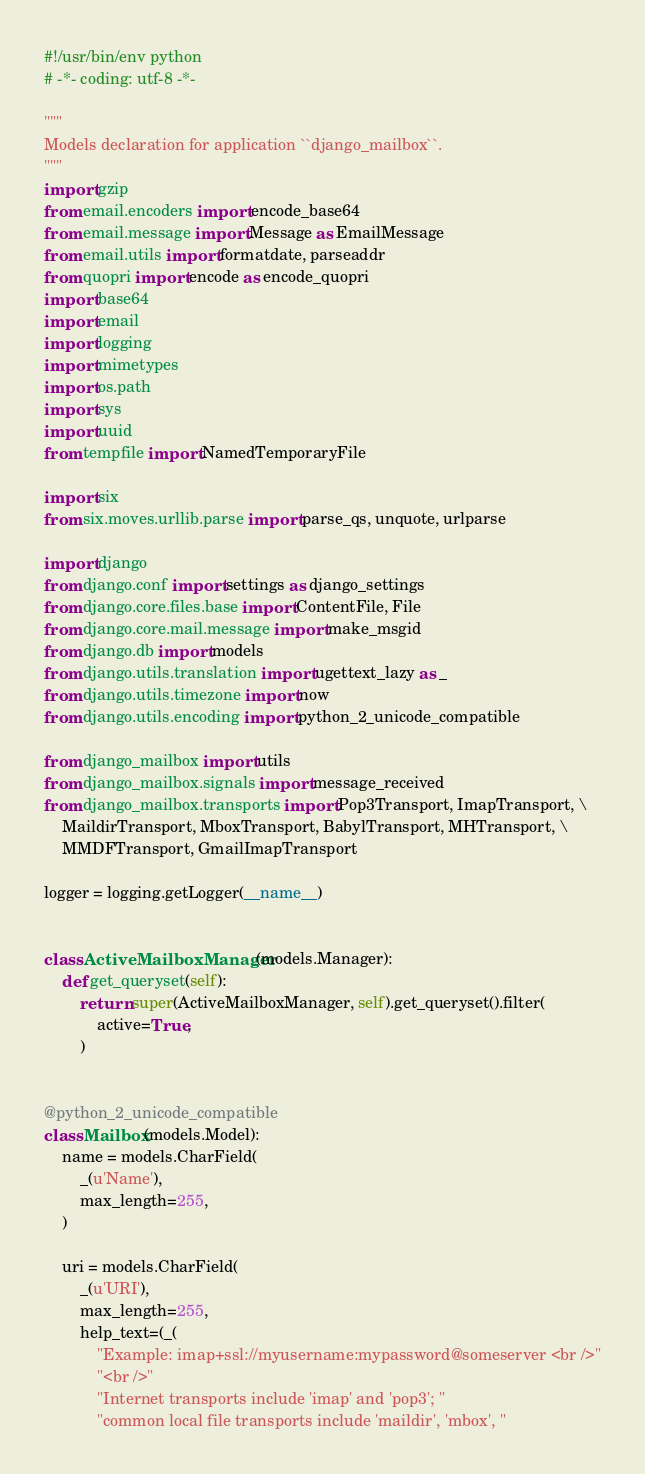<code> <loc_0><loc_0><loc_500><loc_500><_Python_>#!/usr/bin/env python
# -*- coding: utf-8 -*-

"""
Models declaration for application ``django_mailbox``.
"""
import gzip
from email.encoders import encode_base64
from email.message import Message as EmailMessage
from email.utils import formatdate, parseaddr
from quopri import encode as encode_quopri
import base64
import email
import logging
import mimetypes
import os.path
import sys
import uuid
from tempfile import NamedTemporaryFile

import six
from six.moves.urllib.parse import parse_qs, unquote, urlparse

import django
from django.conf import settings as django_settings
from django.core.files.base import ContentFile, File
from django.core.mail.message import make_msgid
from django.db import models
from django.utils.translation import ugettext_lazy as _
from django.utils.timezone import now
from django.utils.encoding import python_2_unicode_compatible

from django_mailbox import utils
from django_mailbox.signals import message_received
from django_mailbox.transports import Pop3Transport, ImapTransport, \
    MaildirTransport, MboxTransport, BabylTransport, MHTransport, \
    MMDFTransport, GmailImapTransport

logger = logging.getLogger(__name__)


class ActiveMailboxManager(models.Manager):
    def get_queryset(self):
        return super(ActiveMailboxManager, self).get_queryset().filter(
            active=True,
        )


@python_2_unicode_compatible
class Mailbox(models.Model):
    name = models.CharField(
        _(u'Name'),
        max_length=255,
    )

    uri = models.CharField(
        _(u'URI'),
        max_length=255,
        help_text=(_(
            "Example: imap+ssl://myusername:mypassword@someserver <br />"
            "<br />"
            "Internet transports include 'imap' and 'pop3'; "
            "common local file transports include 'maildir', 'mbox', "</code> 